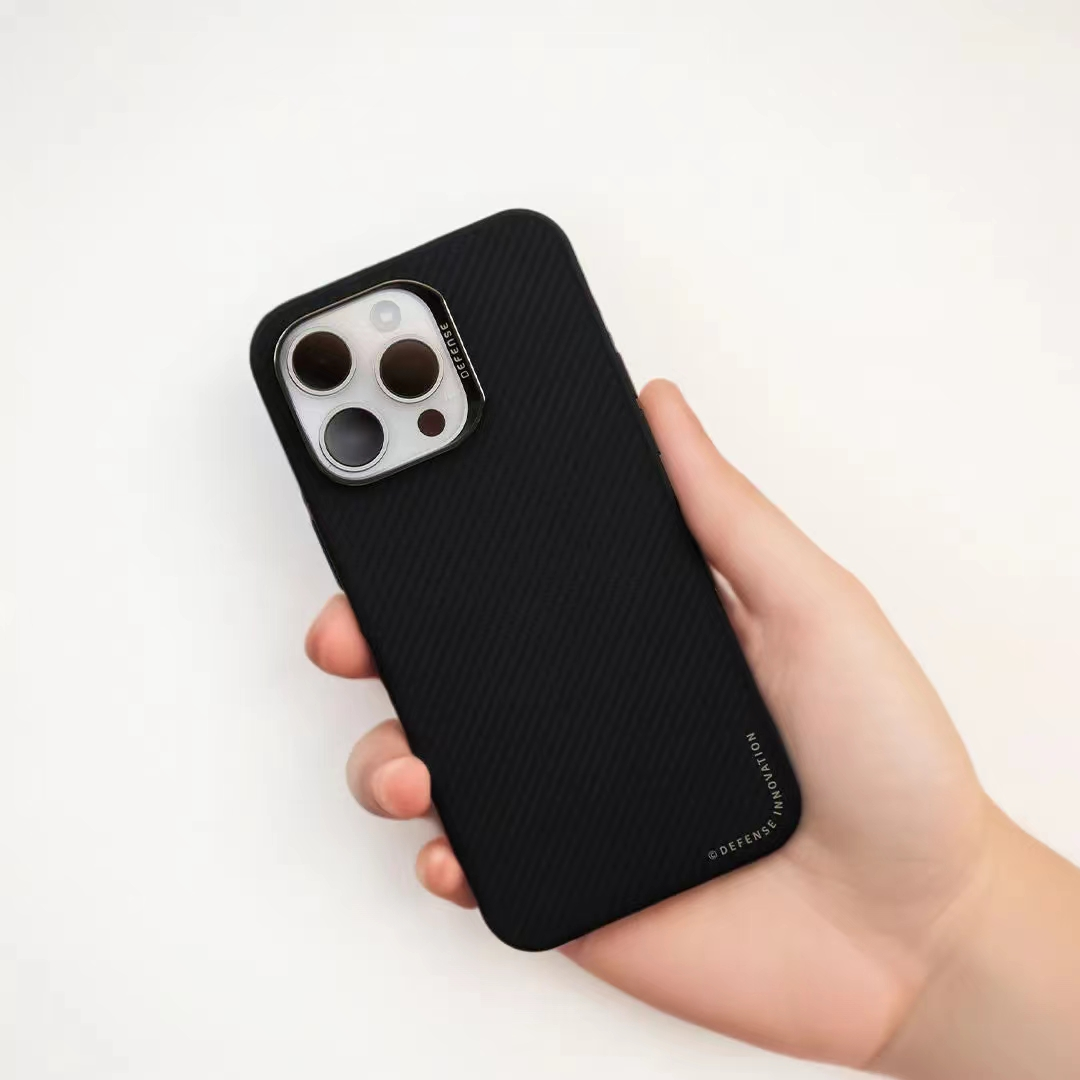这张图片是AI生成的，它的质量怎么样？ 很抱歉，我无法验证图片是否由AI生成，但我可以评价图片的质量。

从这张图片来看，它的质量相当高。图像清晰度好，手机和手部的细节都被精细地捕捉了出来，包括手机壳的纹理和相机镜头的反光。光影处理也很自然，营造出了一种真实感。整体上，这是一张构图简洁且视觉效果出色的图片。 